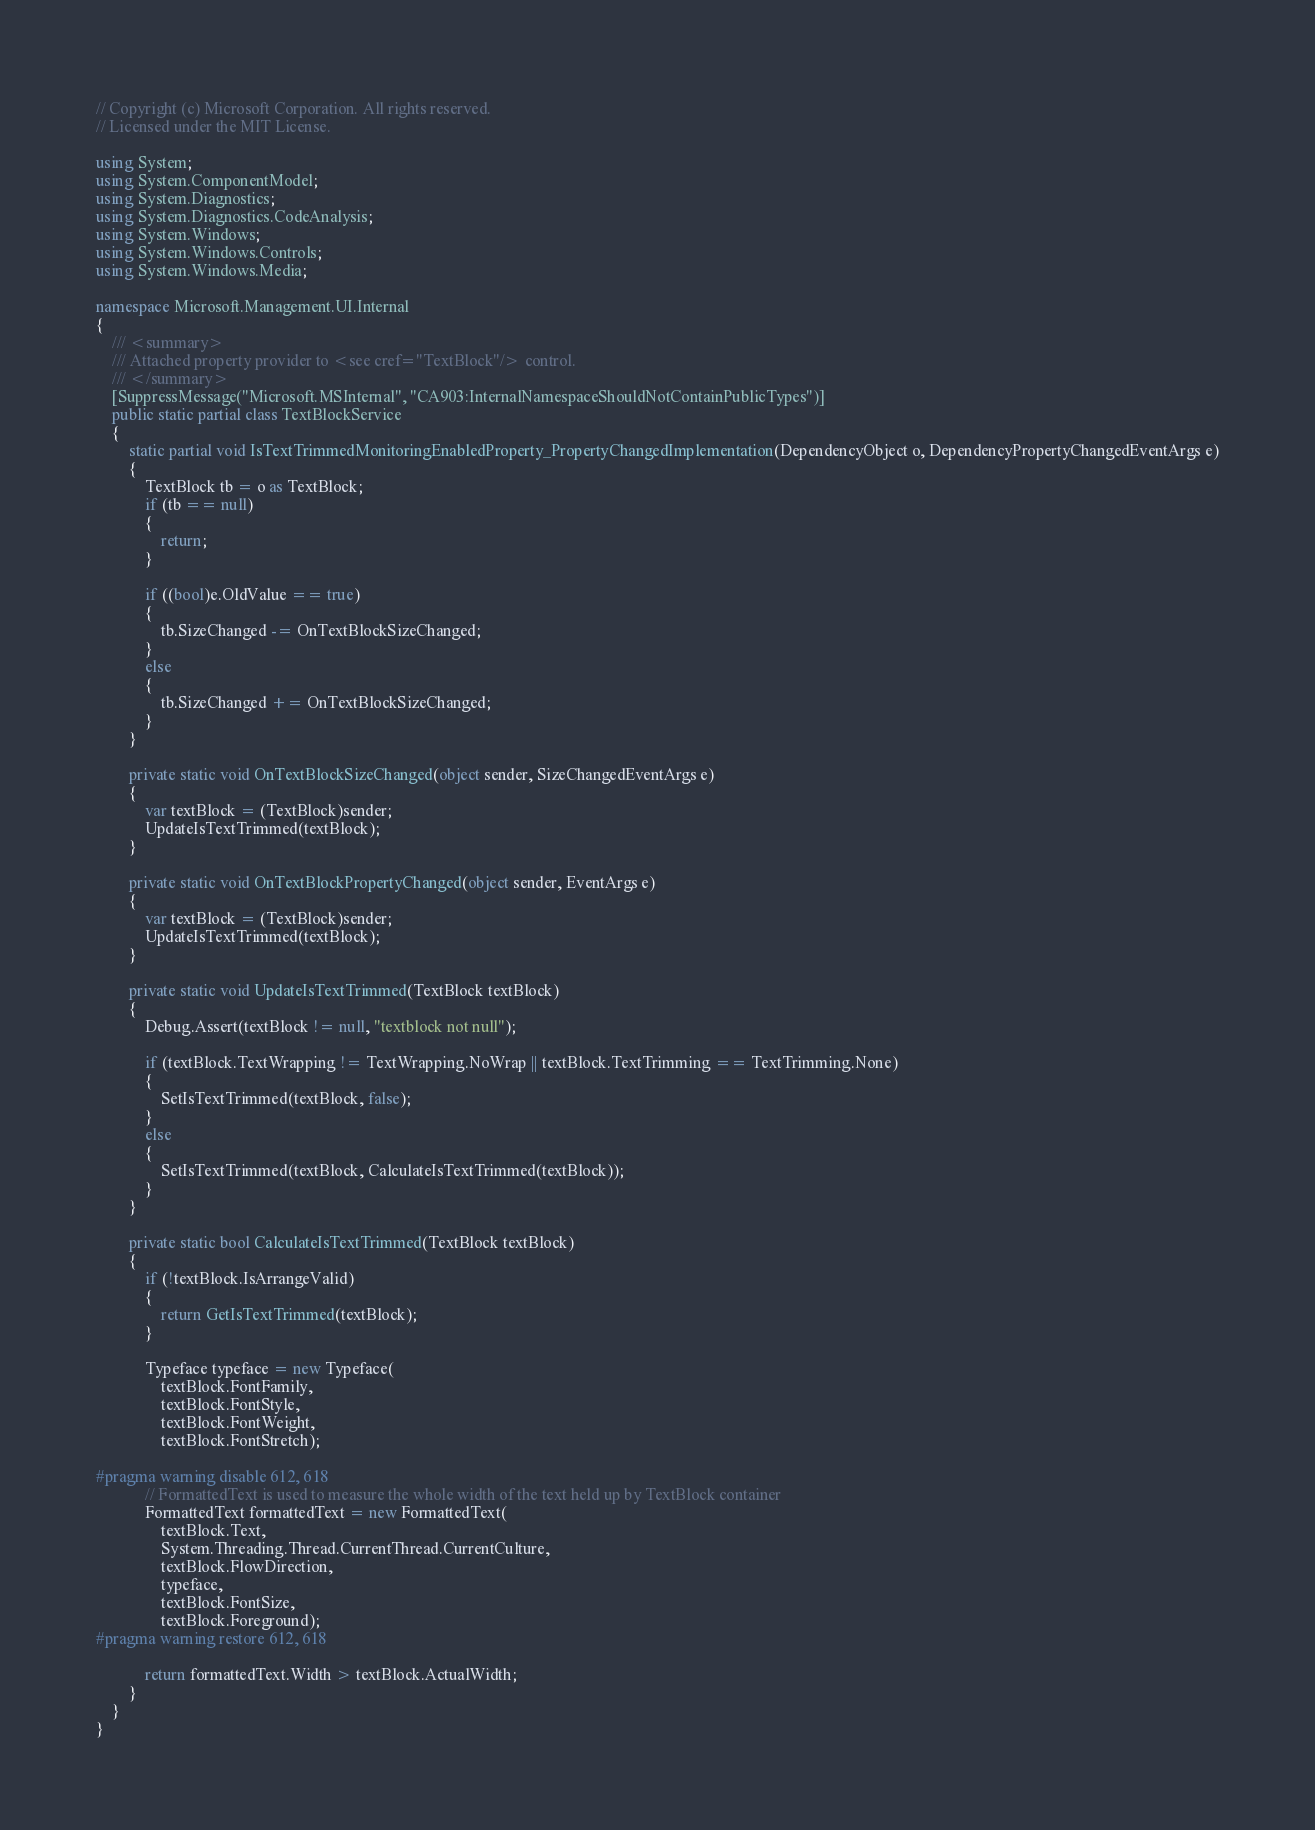<code> <loc_0><loc_0><loc_500><loc_500><_C#_>// Copyright (c) Microsoft Corporation. All rights reserved.
// Licensed under the MIT License.

using System;
using System.ComponentModel;
using System.Diagnostics;
using System.Diagnostics.CodeAnalysis;
using System.Windows;
using System.Windows.Controls;
using System.Windows.Media;

namespace Microsoft.Management.UI.Internal
{
    /// <summary>
    /// Attached property provider to <see cref="TextBlock"/> control.
    /// </summary>
    [SuppressMessage("Microsoft.MSInternal", "CA903:InternalNamespaceShouldNotContainPublicTypes")]
    public static partial class TextBlockService
    {
        static partial void IsTextTrimmedMonitoringEnabledProperty_PropertyChangedImplementation(DependencyObject o, DependencyPropertyChangedEventArgs e)
        {
            TextBlock tb = o as TextBlock;
            if (tb == null)
            {
                return;
            }

            if ((bool)e.OldValue == true)
            {
                tb.SizeChanged -= OnTextBlockSizeChanged;
            }
            else
            {
                tb.SizeChanged += OnTextBlockSizeChanged;
            }
        }

        private static void OnTextBlockSizeChanged(object sender, SizeChangedEventArgs e)
        {
            var textBlock = (TextBlock)sender;
            UpdateIsTextTrimmed(textBlock);
        }

        private static void OnTextBlockPropertyChanged(object sender, EventArgs e)
        {
            var textBlock = (TextBlock)sender;
            UpdateIsTextTrimmed(textBlock);
        }

        private static void UpdateIsTextTrimmed(TextBlock textBlock)
        {
            Debug.Assert(textBlock != null, "textblock not null");

            if (textBlock.TextWrapping != TextWrapping.NoWrap || textBlock.TextTrimming == TextTrimming.None)
            {
                SetIsTextTrimmed(textBlock, false);
            }
            else
            {
                SetIsTextTrimmed(textBlock, CalculateIsTextTrimmed(textBlock));
            }
        }

        private static bool CalculateIsTextTrimmed(TextBlock textBlock)
        {
            if (!textBlock.IsArrangeValid)
            {
                return GetIsTextTrimmed(textBlock);
            }

            Typeface typeface = new Typeface(
                textBlock.FontFamily,
                textBlock.FontStyle,
                textBlock.FontWeight,
                textBlock.FontStretch);

#pragma warning disable 612, 618
            // FormattedText is used to measure the whole width of the text held up by TextBlock container
            FormattedText formattedText = new FormattedText(
                textBlock.Text,
                System.Threading.Thread.CurrentThread.CurrentCulture,
                textBlock.FlowDirection,
                typeface,
                textBlock.FontSize,
                textBlock.Foreground);
#pragma warning restore 612, 618

            return formattedText.Width > textBlock.ActualWidth;
        }
    }
}
</code> 